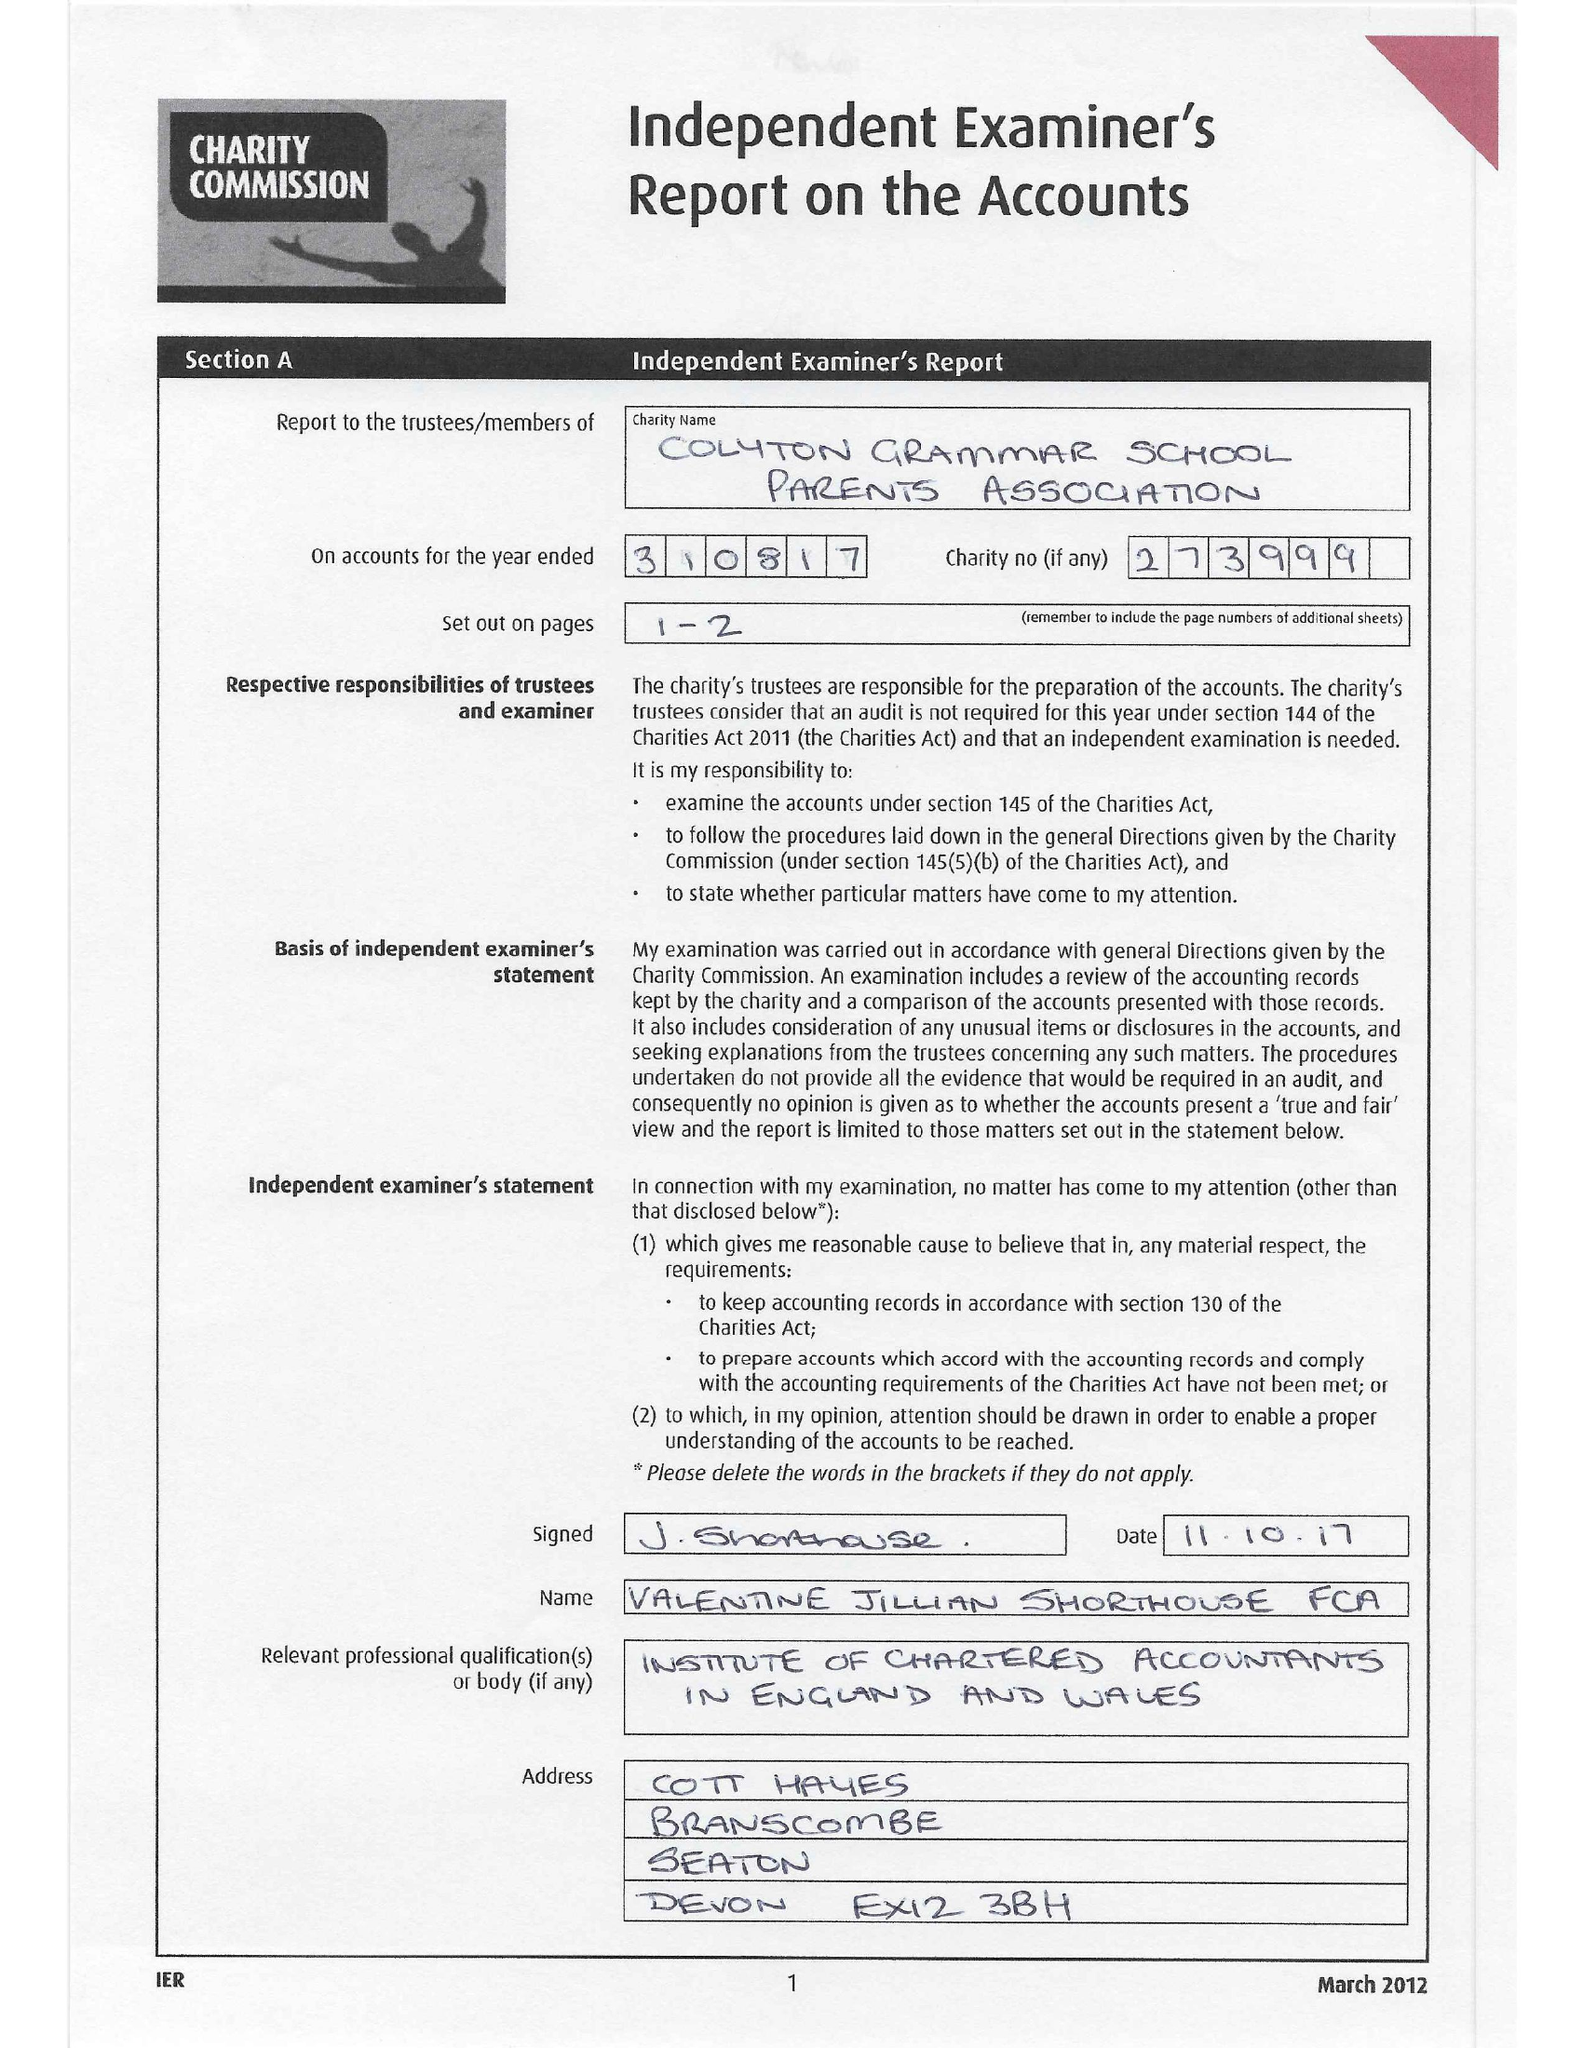What is the value for the income_annually_in_british_pounds?
Answer the question using a single word or phrase. 36141.00 